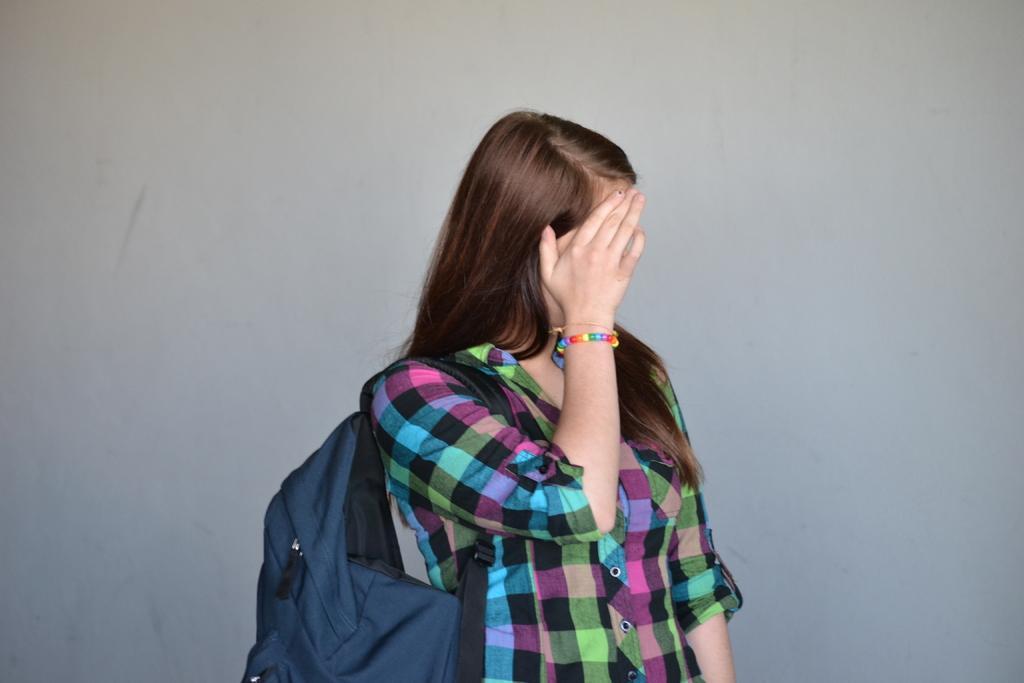How would you summarize this image in a sentence or two? In this image in the front there is a woman standing and wearing a bag which is blue in colour and hiding her face. 